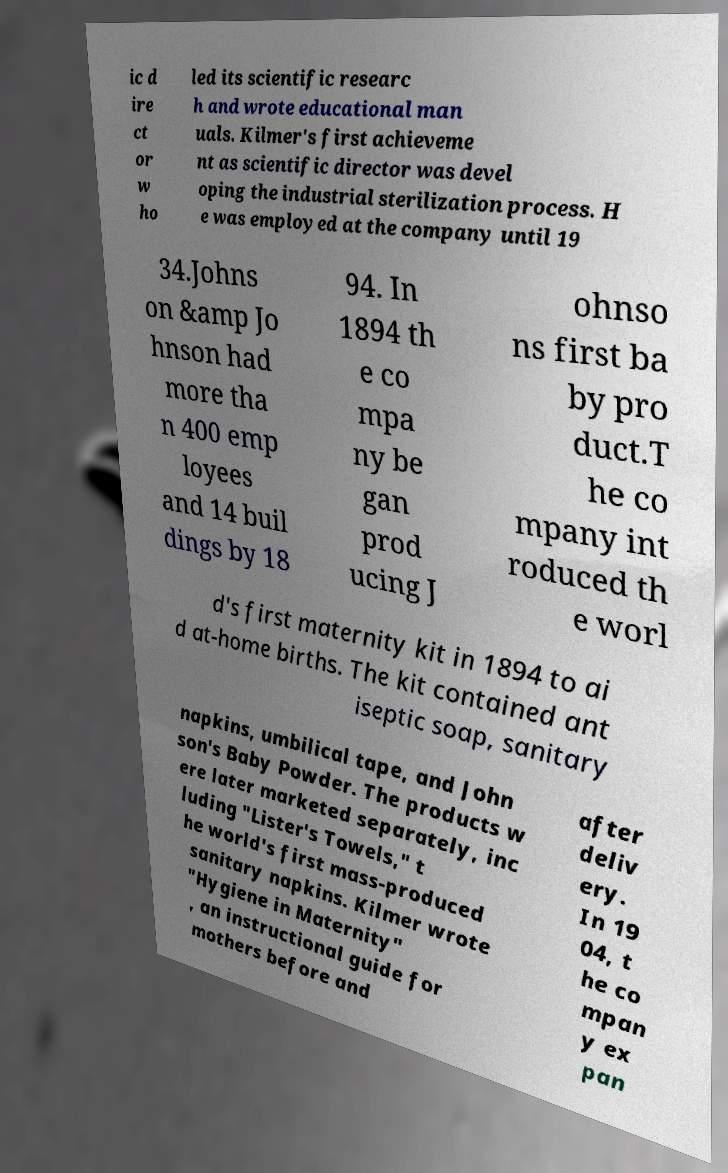Could you extract and type out the text from this image? ic d ire ct or w ho led its scientific researc h and wrote educational man uals. Kilmer's first achieveme nt as scientific director was devel oping the industrial sterilization process. H e was employed at the company until 19 34.Johns on &amp Jo hnson had more tha n 400 emp loyees and 14 buil dings by 18 94. In 1894 th e co mpa ny be gan prod ucing J ohnso ns first ba by pro duct.T he co mpany int roduced th e worl d's first maternity kit in 1894 to ai d at-home births. The kit contained ant iseptic soap, sanitary napkins, umbilical tape, and John son's Baby Powder. The products w ere later marketed separately, inc luding "Lister's Towels," t he world's first mass-produced sanitary napkins. Kilmer wrote "Hygiene in Maternity" , an instructional guide for mothers before and after deliv ery. In 19 04, t he co mpan y ex pan 